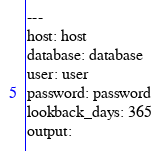Convert code to text. <code><loc_0><loc_0><loc_500><loc_500><_YAML_>---
host: host
database: database
user: user
password: password
lookback_days: 365
output:
</code> 